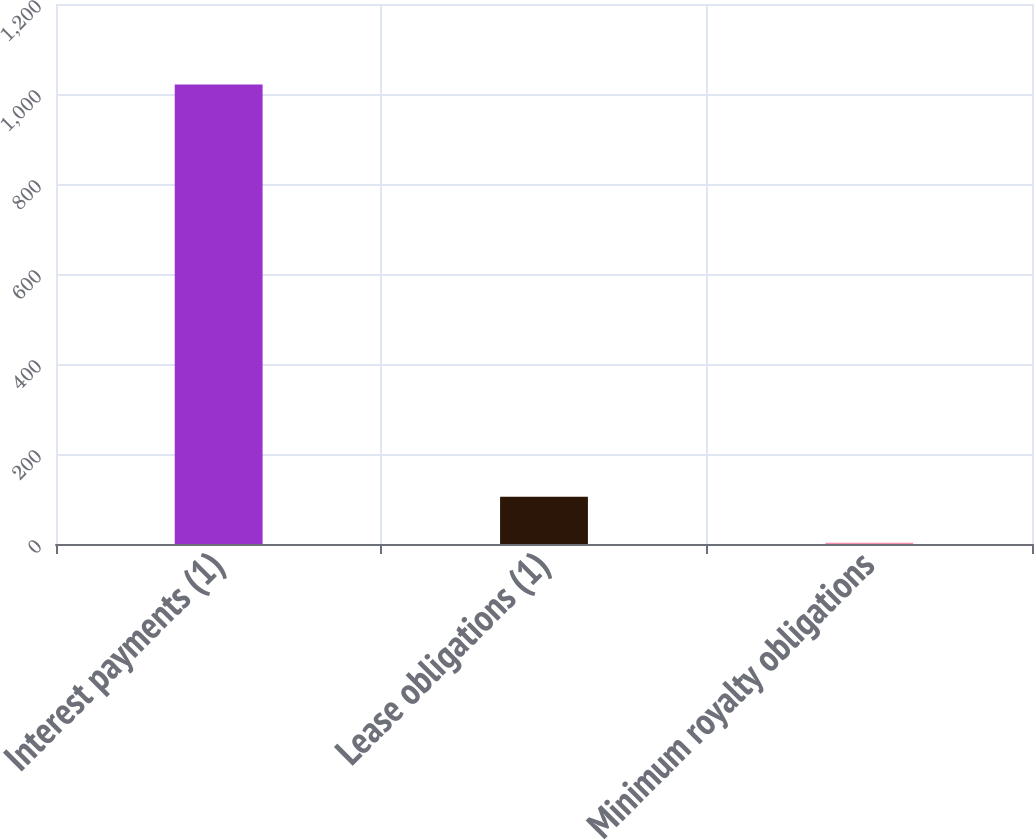<chart> <loc_0><loc_0><loc_500><loc_500><bar_chart><fcel>Interest payments (1)<fcel>Lease obligations (1)<fcel>Minimum royalty obligations<nl><fcel>1021<fcel>104.8<fcel>3<nl></chart> 